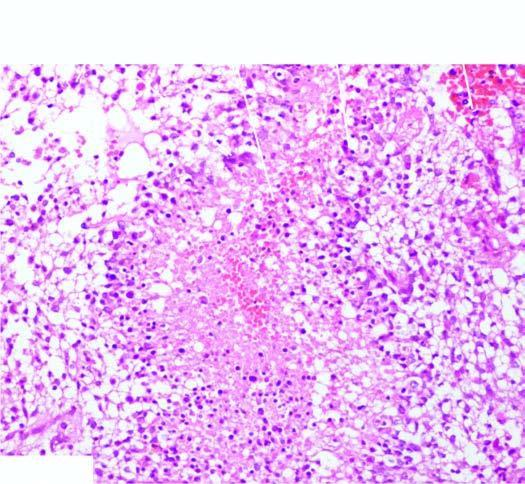s the tumour densely cellular having marked pleomorphism?
Answer the question using a single word or phrase. Yes 